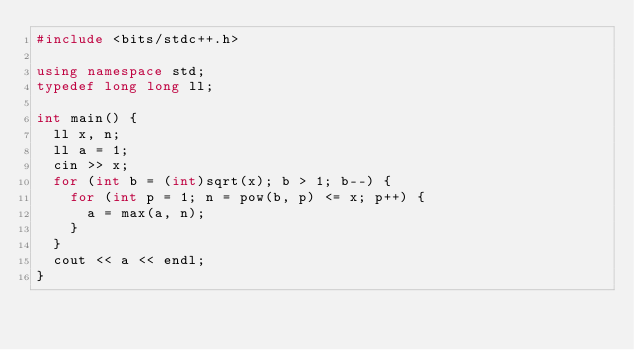Convert code to text. <code><loc_0><loc_0><loc_500><loc_500><_C++_>#include <bits/stdc++.h>

using namespace std;
typedef long long ll;

int main() {
  ll x, n;
  ll a = 1;
  cin >> x;
  for (int b = (int)sqrt(x); b > 1; b--) {
    for (int p = 1; n = pow(b, p) <= x; p++) {
      a = max(a, n);
    }
  }
  cout << a << endl;
}</code> 